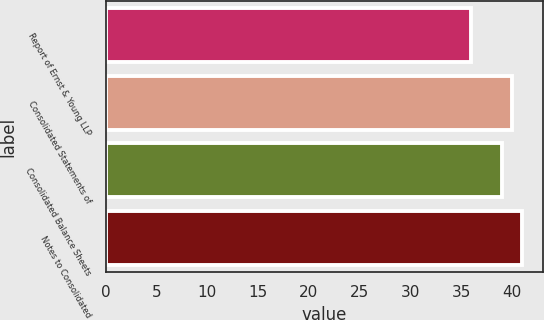Convert chart to OTSL. <chart><loc_0><loc_0><loc_500><loc_500><bar_chart><fcel>Report of Ernst & Young LLP<fcel>Consolidated Statements of<fcel>Consolidated Balance Sheets<fcel>Notes to Consolidated<nl><fcel>36<fcel>40<fcel>39<fcel>41<nl></chart> 